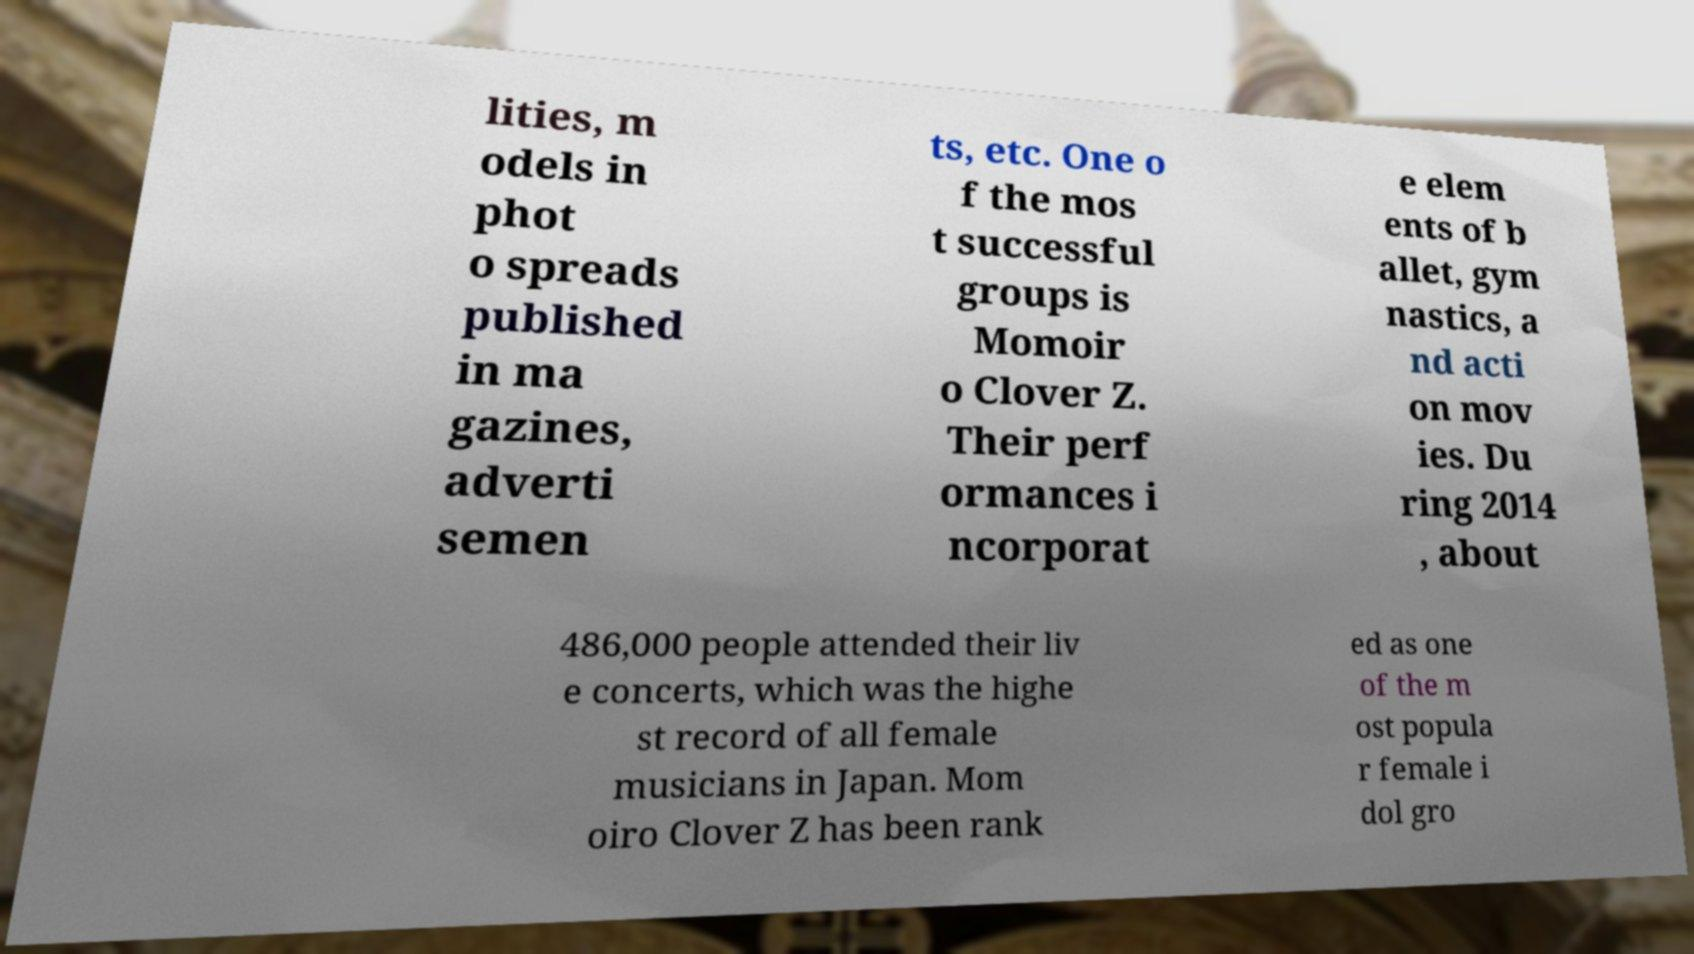Can you accurately transcribe the text from the provided image for me? lities, m odels in phot o spreads published in ma gazines, adverti semen ts, etc. One o f the mos t successful groups is Momoir o Clover Z. Their perf ormances i ncorporat e elem ents of b allet, gym nastics, a nd acti on mov ies. Du ring 2014 , about 486,000 people attended their liv e concerts, which was the highe st record of all female musicians in Japan. Mom oiro Clover Z has been rank ed as one of the m ost popula r female i dol gro 